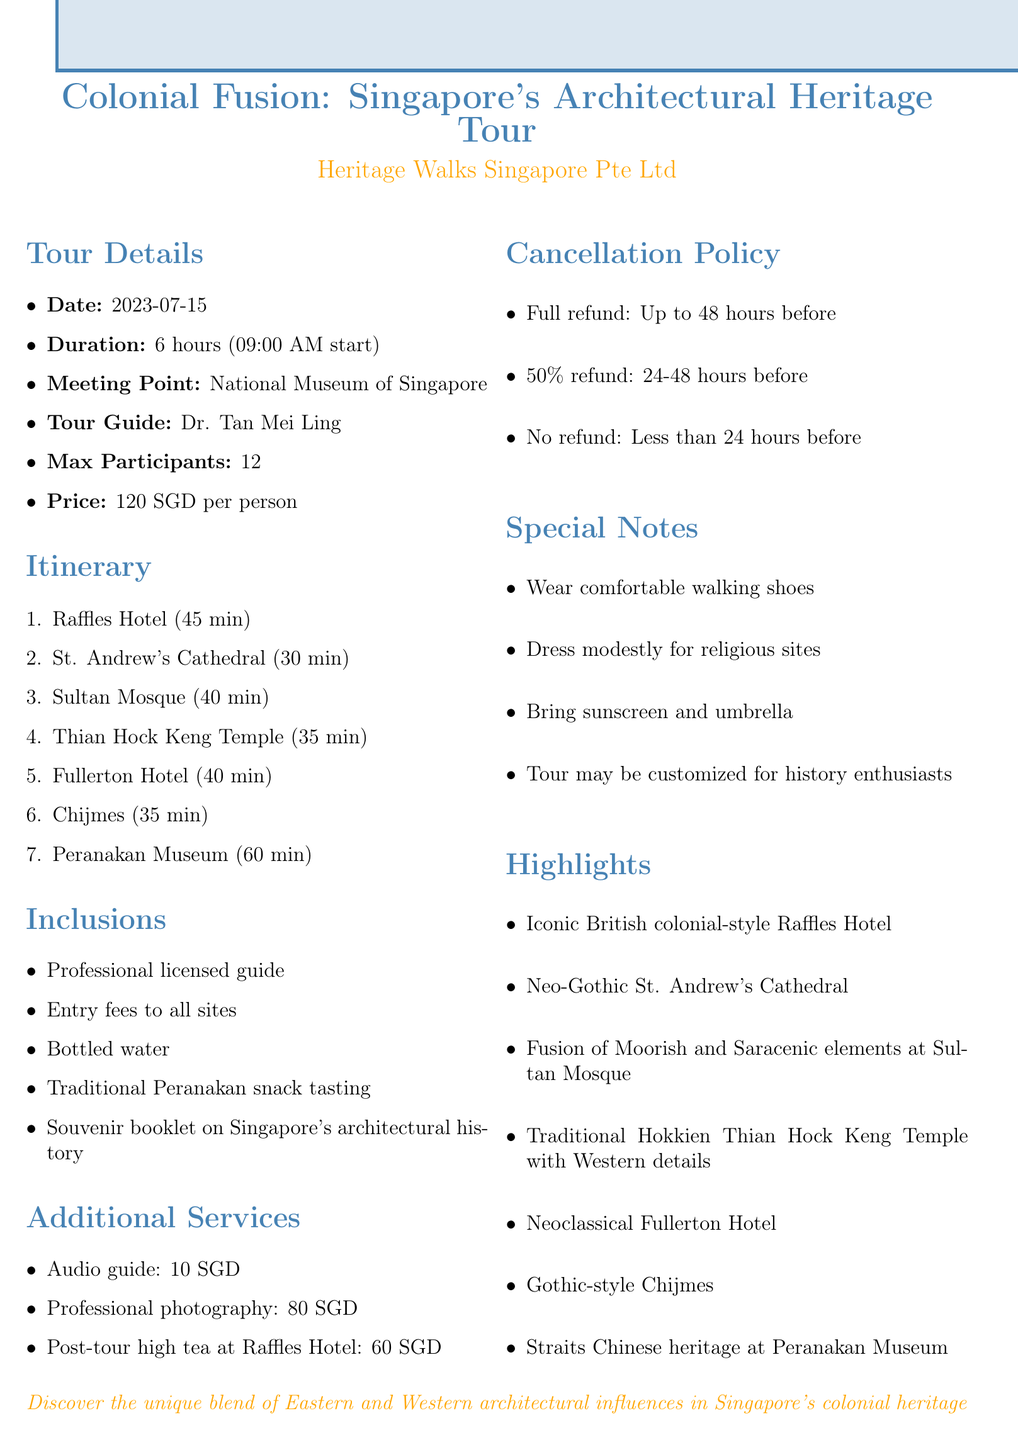What is the name of the tour? The name of the tour is specified in the document.
Answer: Colonial Fusion: Singapore's Architectural Heritage Tour Who is the tour guide? The tour guide is mentioned in the document under tour details.
Answer: Dr. Tan Mei Ling What is the price per person? The price per person is clearly stated in the document.
Answer: 120 SGD How long is the tour? The duration of the tour is provided in the document.
Answer: 6 hours What is the maximum number of participants? The maximum number of participants is specified in the document.
Answer: 12 What type of architecture is featured at Sultan Mosque? The document describes the architectural style of Sultan Mosque.
Answer: Fusion of Moorish and Saracenic elements What refund percentage is offered for cancellations made 24-48 hours in advance? The partial refund terms are outlined in the cancellation policy section.
Answer: 50% What additional service costs 10 SGD? The document lists additional services with their prices.
Answer: Audio guide in multiple languages What should participants wear for the tour? The special notes section provides recommendations for participants.
Answer: Comfortable walking shoes 